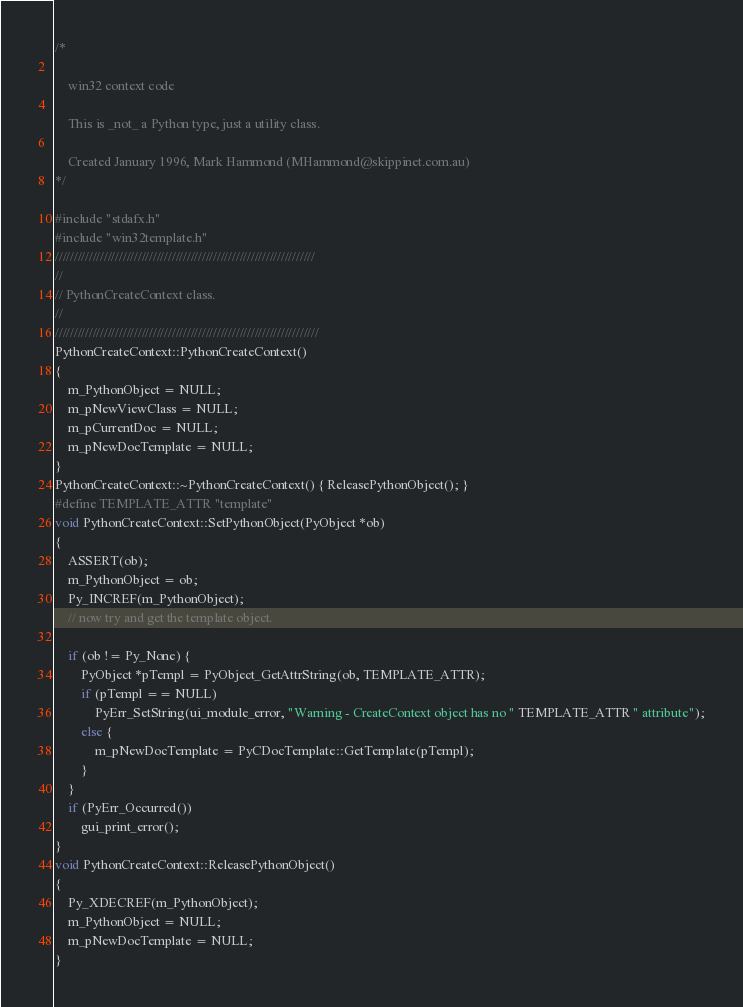Convert code to text. <code><loc_0><loc_0><loc_500><loc_500><_C++_>/*

    win32 context code

    This is _not_ a Python type, just a utility class.

    Created January 1996, Mark Hammond (MHammond@skippinet.com.au)
*/

#include "stdafx.h"
#include "win32template.h"
/////////////////////////////////////////////////////////////////////
//
// PythonCreateContext class.
//
//////////////////////////////////////////////////////////////////////
PythonCreateContext::PythonCreateContext()
{
    m_PythonObject = NULL;
    m_pNewViewClass = NULL;
    m_pCurrentDoc = NULL;
    m_pNewDocTemplate = NULL;
}
PythonCreateContext::~PythonCreateContext() { ReleasePythonObject(); }
#define TEMPLATE_ATTR "template"
void PythonCreateContext::SetPythonObject(PyObject *ob)
{
    ASSERT(ob);
    m_PythonObject = ob;
    Py_INCREF(m_PythonObject);
    // now try and get the template object.

    if (ob != Py_None) {
        PyObject *pTempl = PyObject_GetAttrString(ob, TEMPLATE_ATTR);
        if (pTempl == NULL)
            PyErr_SetString(ui_module_error, "Warning - CreateContext object has no " TEMPLATE_ATTR " attribute");
        else {
            m_pNewDocTemplate = PyCDocTemplate::GetTemplate(pTempl);
        }
    }
    if (PyErr_Occurred())
        gui_print_error();
}
void PythonCreateContext::ReleasePythonObject()
{
    Py_XDECREF(m_PythonObject);
    m_PythonObject = NULL;
    m_pNewDocTemplate = NULL;
}
</code> 